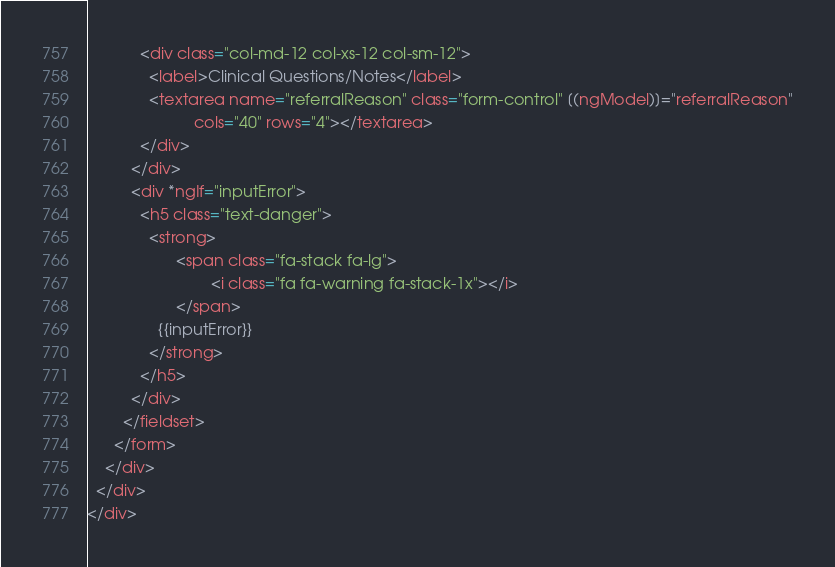<code> <loc_0><loc_0><loc_500><loc_500><_HTML_>            <div class="col-md-12 col-xs-12 col-sm-12">
              <label>Clinical Questions/Notes</label>
              <textarea name="referralReason" class="form-control" [(ngModel)]="referralReason"
                        cols="40" rows="4"></textarea>
            </div>
          </div>
          <div *ngIf="inputError">
            <h5 class="text-danger">
              <strong>
					<span class="fa-stack fa-lg">
							<i class="fa fa-warning fa-stack-1x"></i>
					</span>
                {{inputError}}
              </strong>
            </h5>
          </div>
        </fieldset>
      </form>
    </div>
  </div>
</div>
</code> 